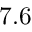<formula> <loc_0><loc_0><loc_500><loc_500>7 . 6</formula> 